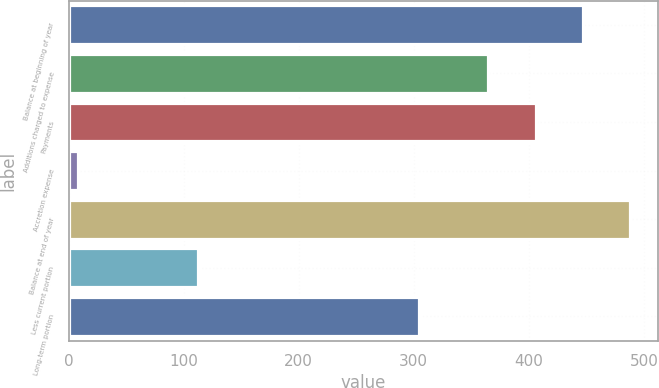<chart> <loc_0><loc_0><loc_500><loc_500><bar_chart><fcel>Balance at beginning of year<fcel>Additions charged to expense<fcel>Payments<fcel>Accretion expense<fcel>Balance at end of year<fcel>Less current portion<fcel>Long-term portion<nl><fcel>446.68<fcel>364.9<fcel>405.79<fcel>8.3<fcel>487.57<fcel>112.7<fcel>304.5<nl></chart> 